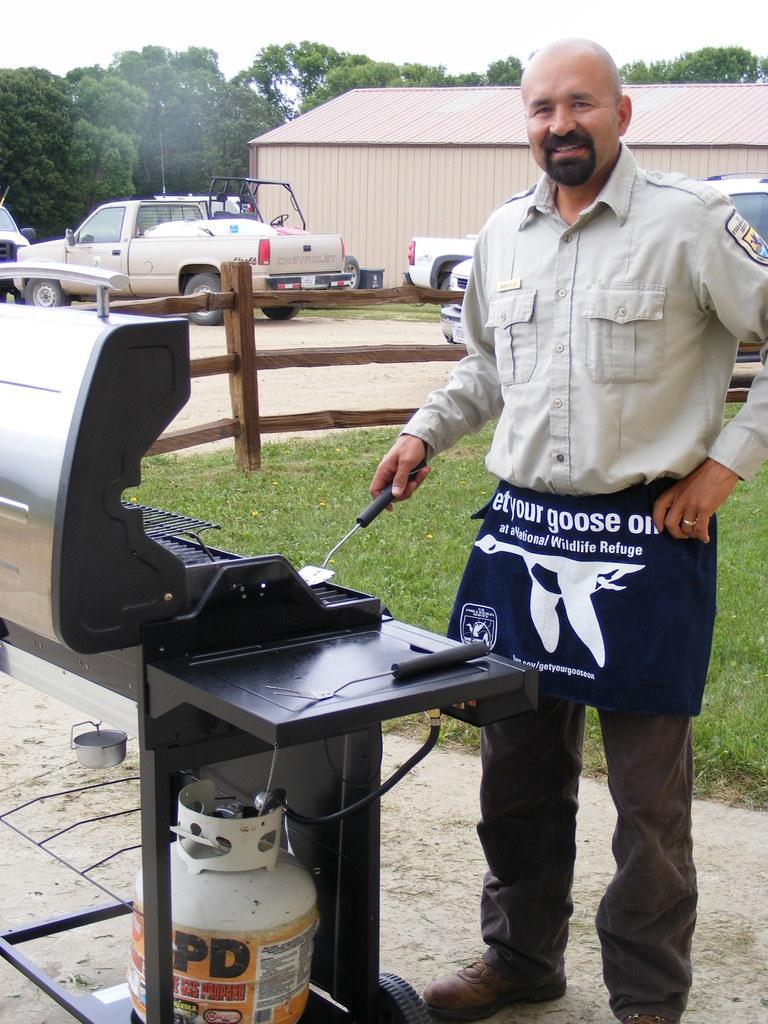<image>
Relay a brief, clear account of the picture shown. A man standing at the grill wears an apron stating "Let your goose out" 